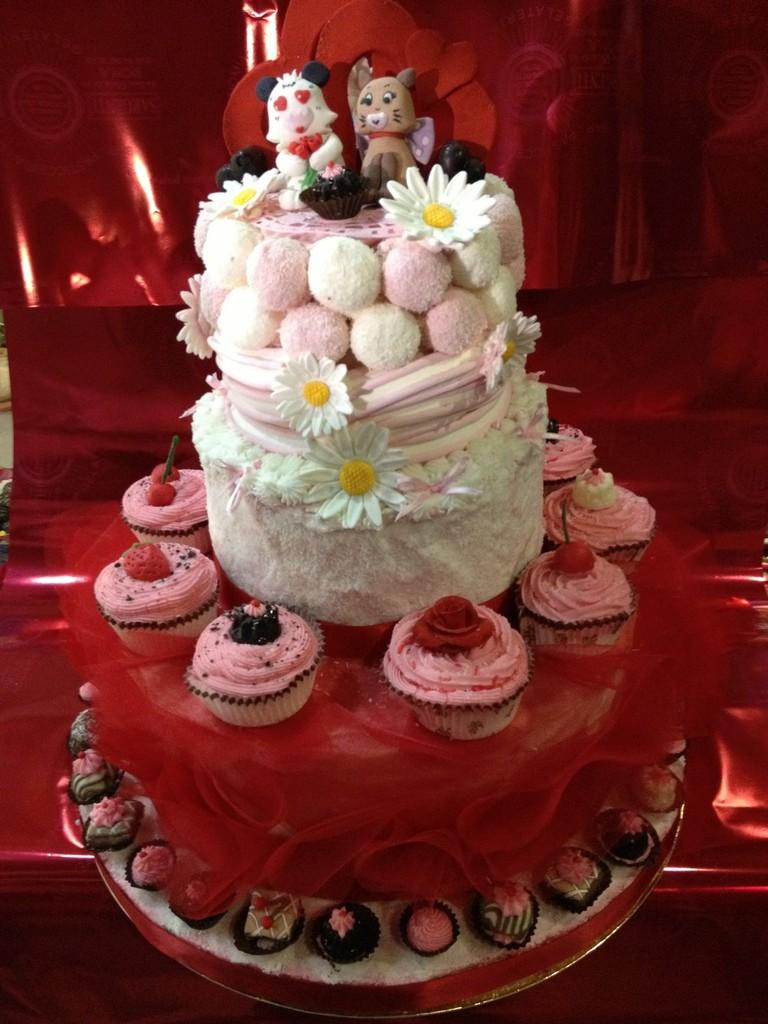What is the main dessert featured in the image? There is a cake in the image. Are there any other desserts visible around the main dessert? Yes, there are cupcakes around the cake. What color is the background of the image? The background color of the image is red. How many bikes are parked next to the cake in the image? There are no bikes present in the image; it only features desserts and a red background. 